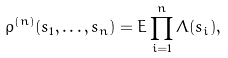Convert formula to latex. <formula><loc_0><loc_0><loc_500><loc_500>\varrho ^ { ( n ) } ( s _ { 1 } , \dots , s _ { n } ) = E \prod _ { i = 1 } ^ { n } \Lambda ( s _ { i } ) ,</formula> 